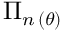Convert formula to latex. <formula><loc_0><loc_0><loc_500><loc_500>\Pi _ { n \, ( \theta ) }</formula> 